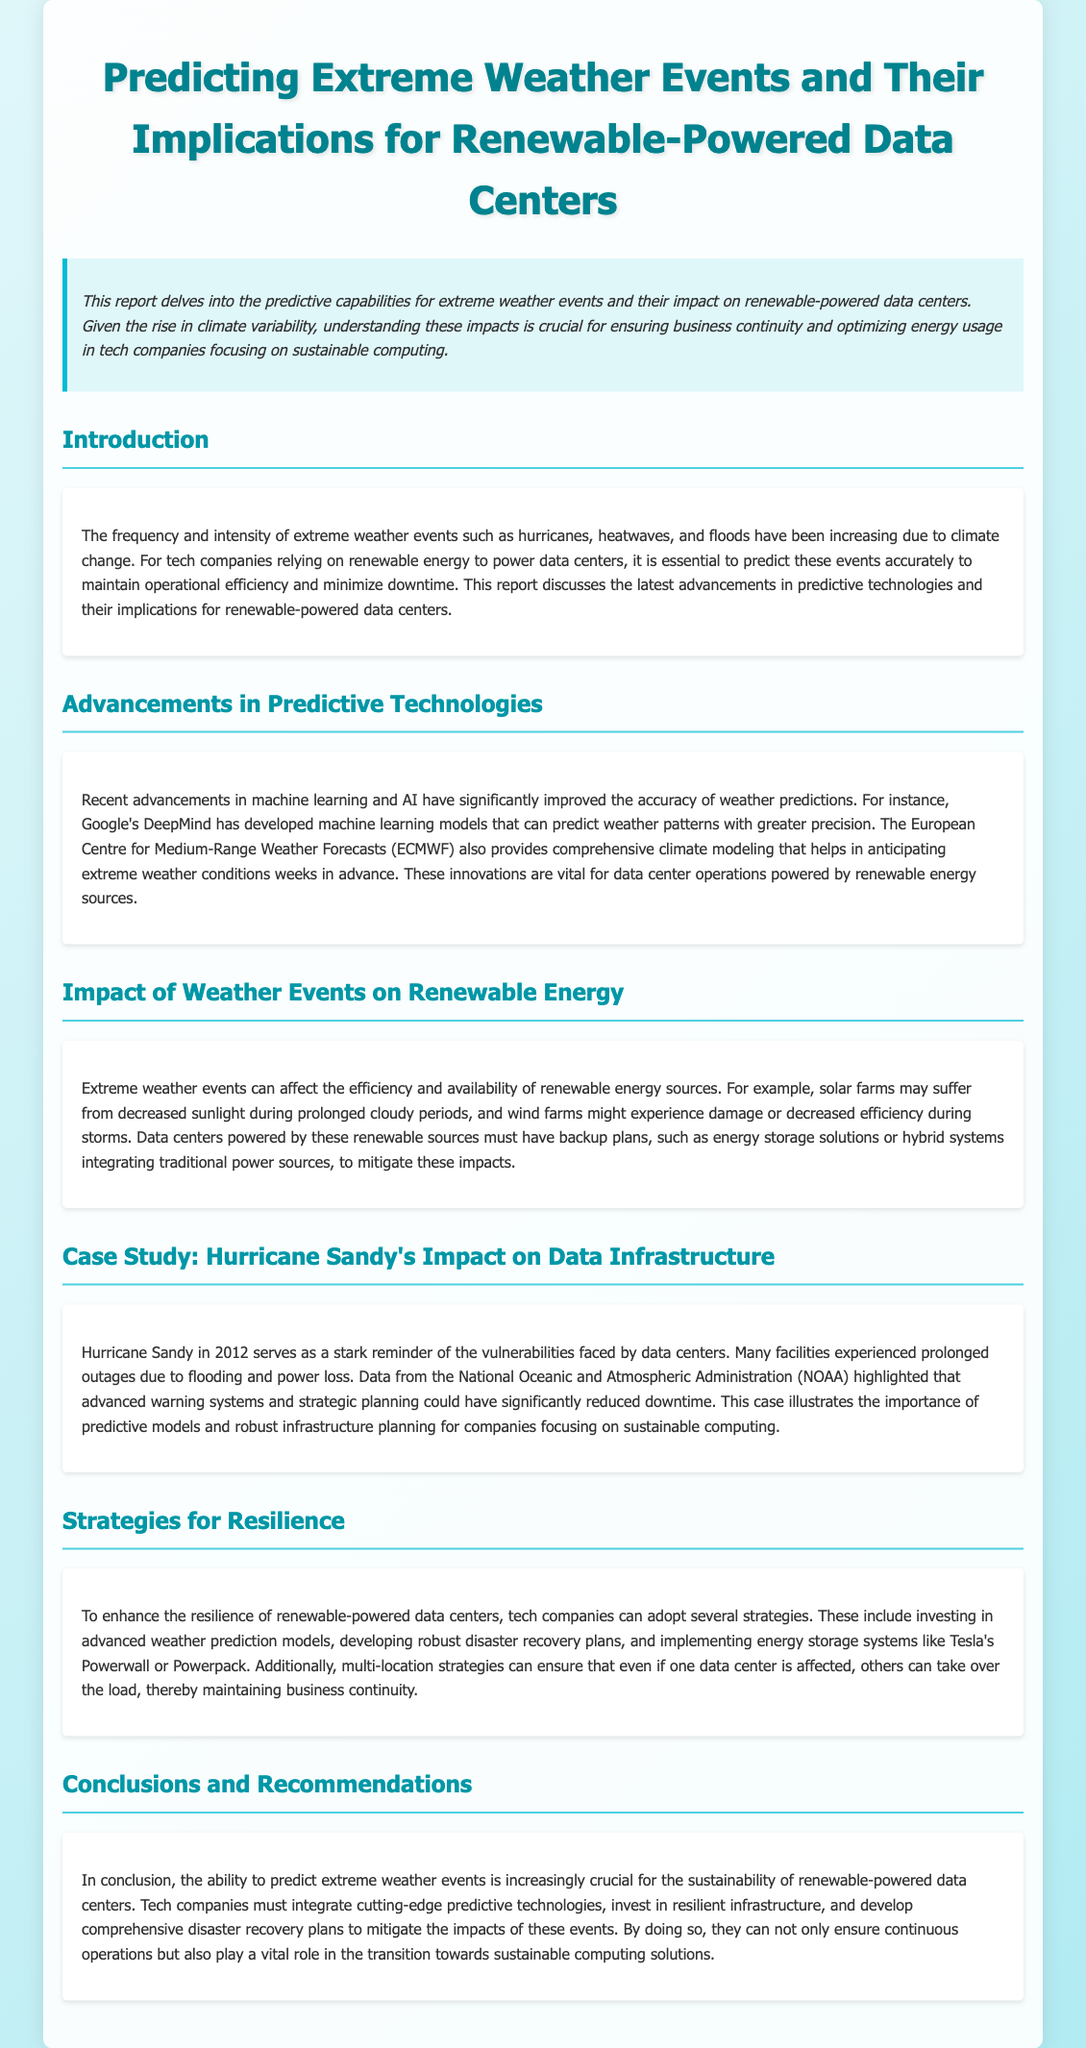What is the title of the report? The title of the report is provided in the header section, reflecting the main theme of the document.
Answer: Predicting Extreme Weather Events and Their Implications for Renewable-Powered Data Centers What major natural events are discussed in the introduction? The introduction highlights various extreme weather events that are becoming more frequent and intense due to climate change.
Answer: hurricanes, heatwaves, floods Which company is mentioned for its advancements in weather prediction? The document specifically refers to a company noted for its significant contributions to improving weather predictions.
Answer: Google's DeepMind What does the case study of Hurricane Sandy illustrate? The case study provides insight into the weaknesses in data infrastructure during extreme weather and emphasizes the importance of preparedness.
Answer: vulnerabilities faced by data centers What is one strategy for enhancing resilience mentioned in the report? The report lists several strategies for resilience; one specific strategy is highlighted for tech companies focusing on operational continuity.
Answer: investing in advanced weather prediction models How can solar farms be affected by extreme weather events? The report discusses potential impacts on solar farms due to specific weather conditions affecting their functionality.
Answer: decreased sunlight during prolonged cloudy periods What does the report recommend integrating for sustainability? The report emphasizes the need for particular technologies and planning techniques to support sustainable operations in data centers.
Answer: cutting-edge predictive technologies Which institution provides comprehensive climate modeling according to the advancements section? The advancements section mentions an organization known for its contributions to weather forecasting.
Answer: European Centre for Medium-Range Weather Forecasts (ECMWF) 